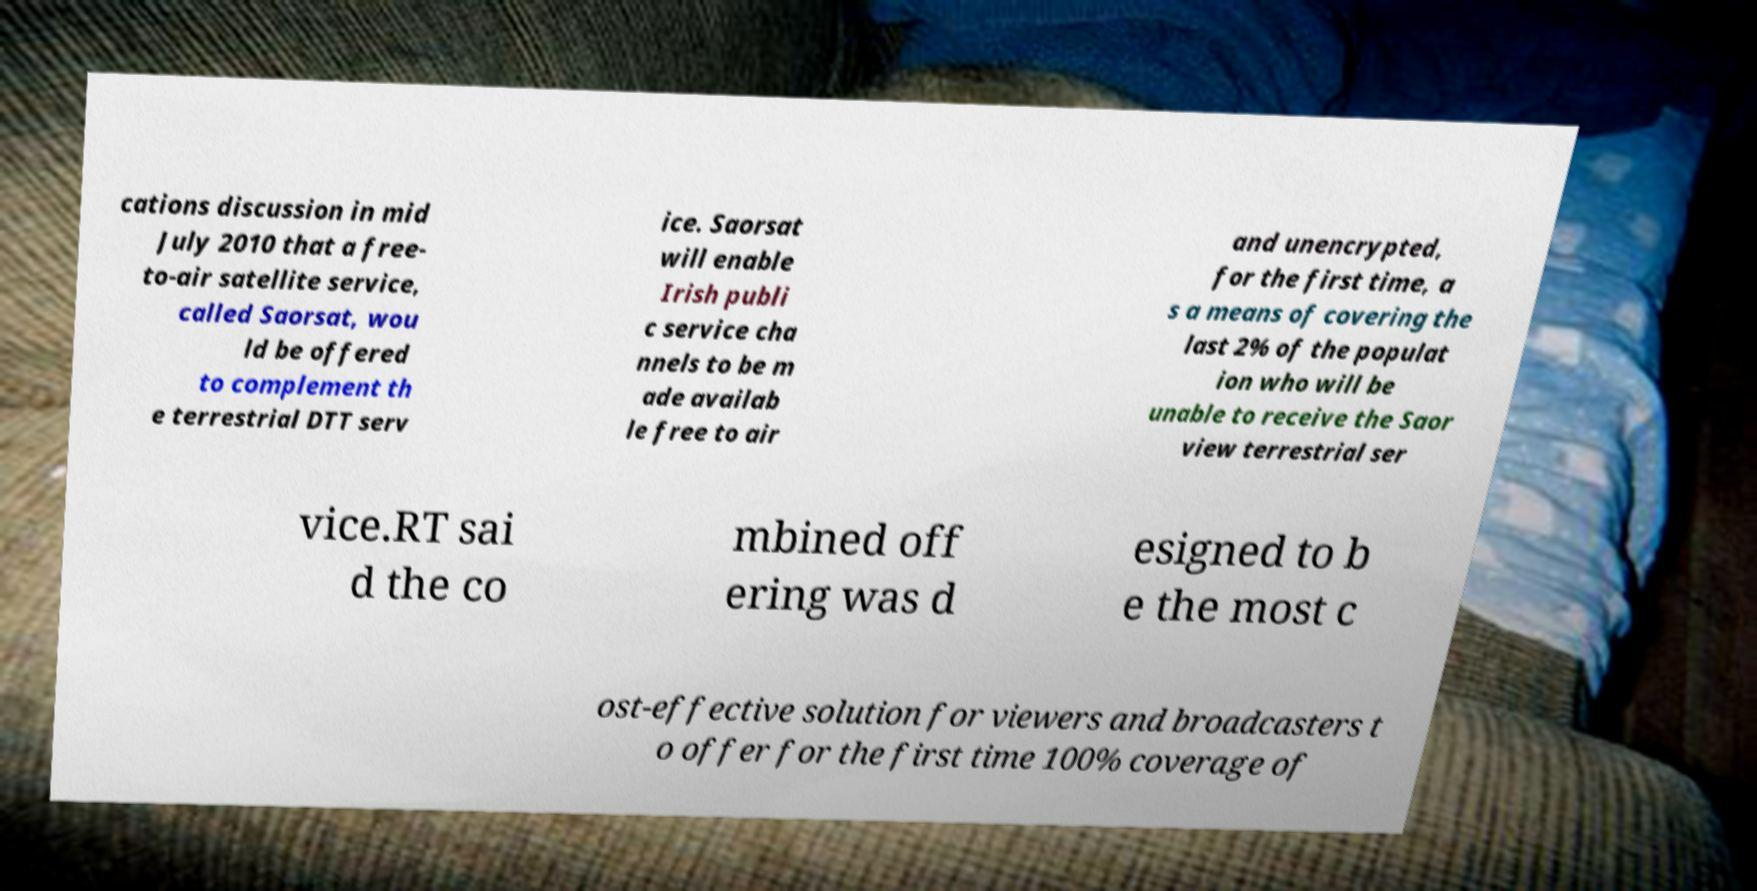Please identify and transcribe the text found in this image. cations discussion in mid July 2010 that a free- to-air satellite service, called Saorsat, wou ld be offered to complement th e terrestrial DTT serv ice. Saorsat will enable Irish publi c service cha nnels to be m ade availab le free to air and unencrypted, for the first time, a s a means of covering the last 2% of the populat ion who will be unable to receive the Saor view terrestrial ser vice.RT sai d the co mbined off ering was d esigned to b e the most c ost-effective solution for viewers and broadcasters t o offer for the first time 100% coverage of 